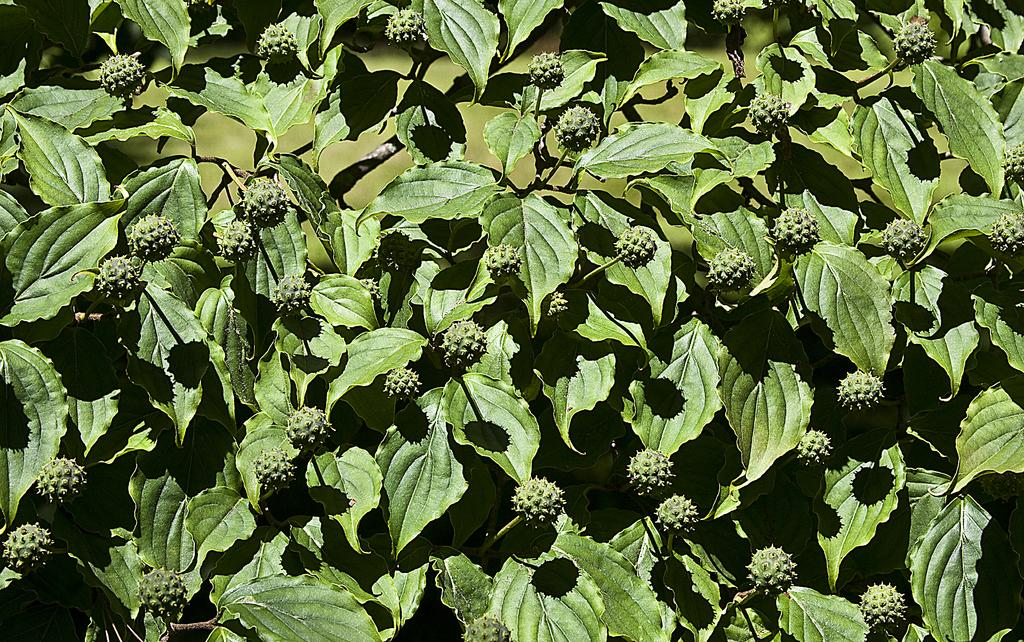What type of plant material is present in the image? There are leaves in the image. What else can be found in the image besides leaves? There are fruits in the image. How many pigs are visible in the image? There are no pigs present in the image. What type of bead is used to decorate the fruits in the image? There is no bead present in the image, as it only features leaves and fruits. 